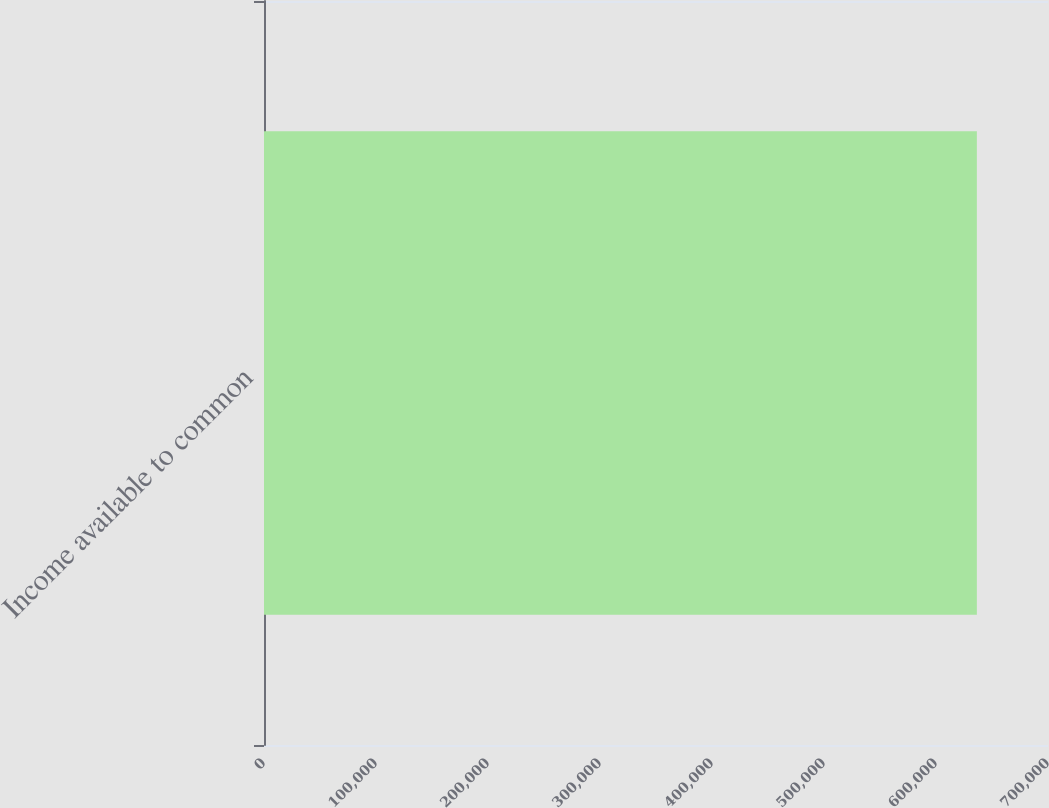Convert chart to OTSL. <chart><loc_0><loc_0><loc_500><loc_500><bar_chart><fcel>Income available to common<nl><fcel>636484<nl></chart> 